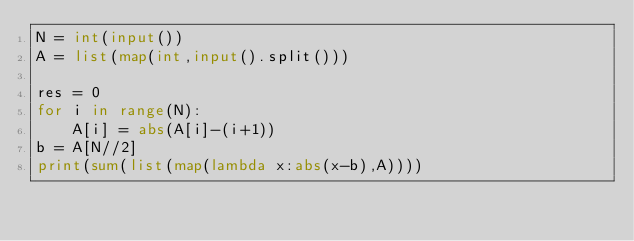Convert code to text. <code><loc_0><loc_0><loc_500><loc_500><_Python_>N = int(input())
A = list(map(int,input().split()))

res = 0
for i in range(N):
    A[i] = abs(A[i]-(i+1))
b = A[N//2]
print(sum(list(map(lambda x:abs(x-b),A))))</code> 